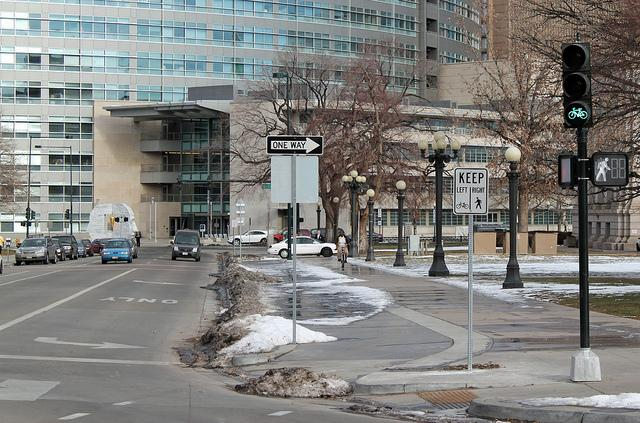What natural event seems to have occurred here? snow 